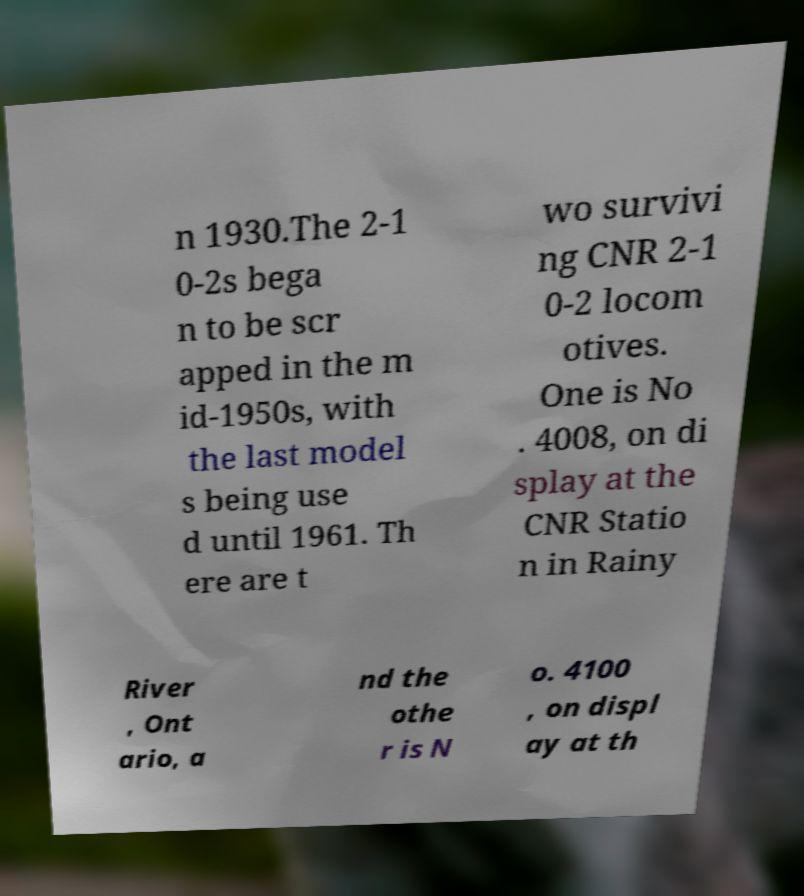Can you accurately transcribe the text from the provided image for me? n 1930.The 2-1 0-2s bega n to be scr apped in the m id-1950s, with the last model s being use d until 1961. Th ere are t wo survivi ng CNR 2-1 0-2 locom otives. One is No . 4008, on di splay at the CNR Statio n in Rainy River , Ont ario, a nd the othe r is N o. 4100 , on displ ay at th 